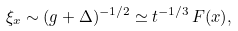<formula> <loc_0><loc_0><loc_500><loc_500>\xi _ { x } \sim ( g + \Delta ) ^ { - 1 / 2 } \simeq { t } ^ { - 1 / 3 } \, F ( x ) ,</formula> 